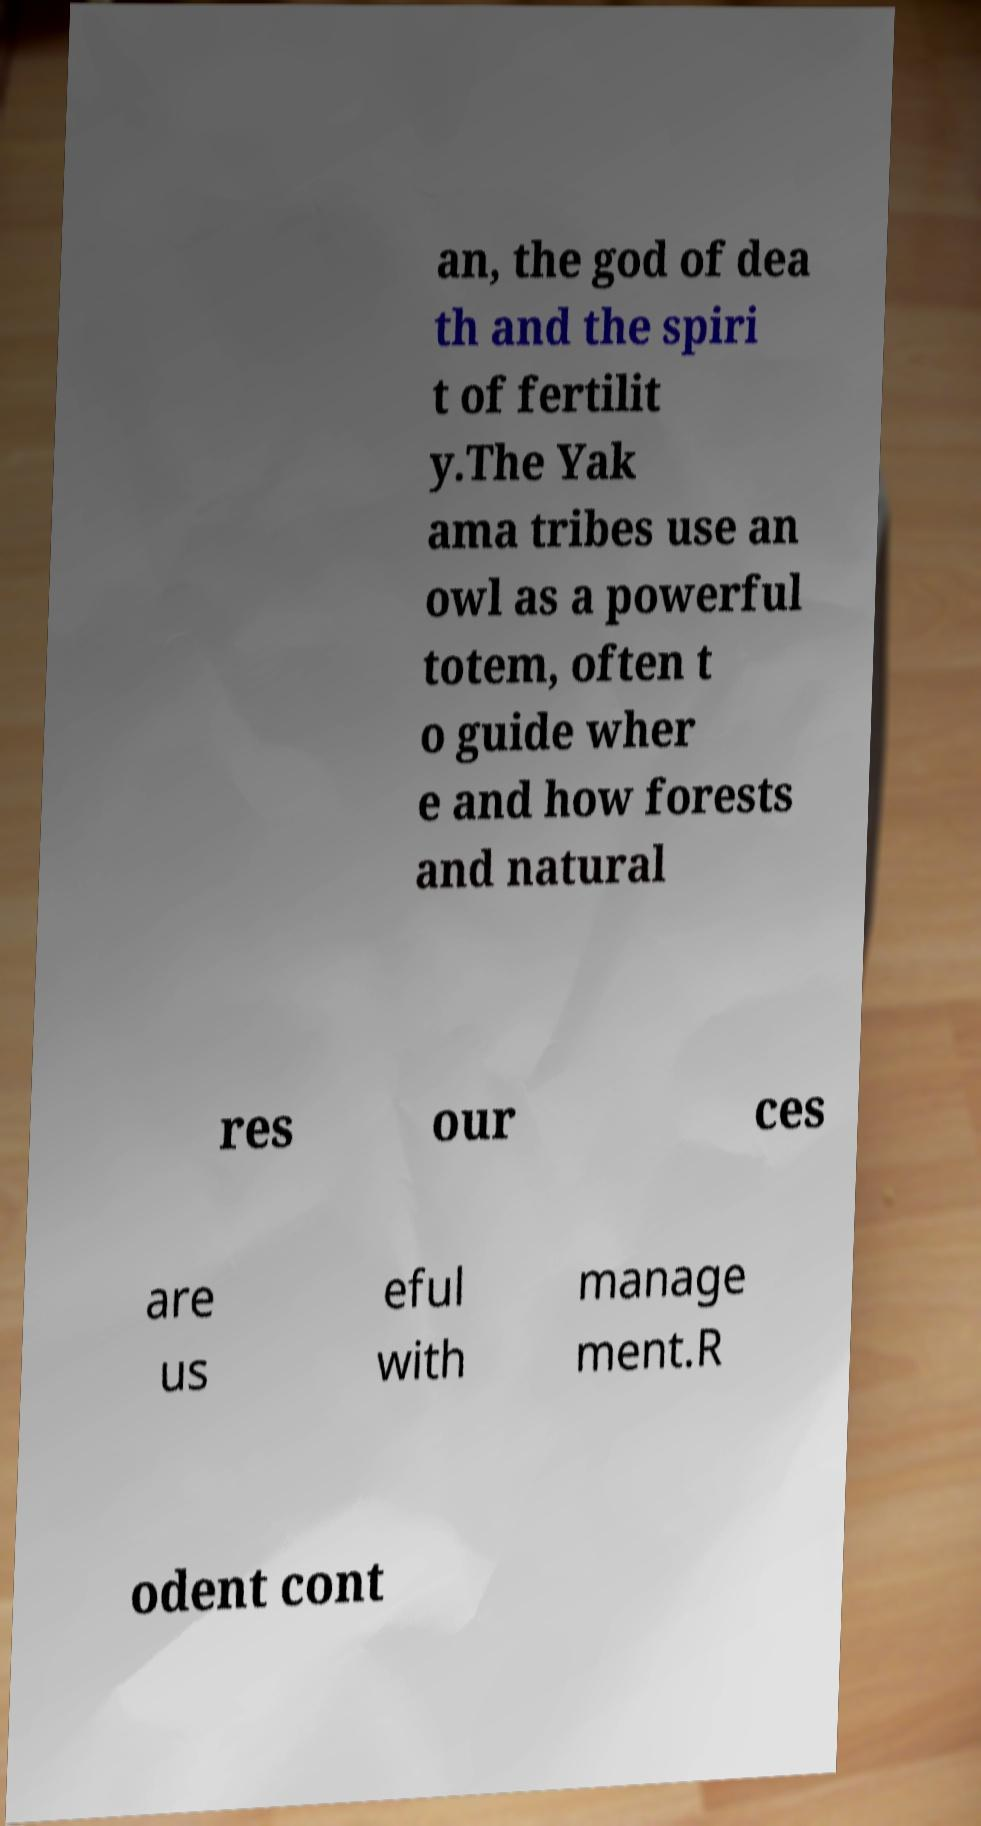I need the written content from this picture converted into text. Can you do that? an, the god of dea th and the spiri t of fertilit y.The Yak ama tribes use an owl as a powerful totem, often t o guide wher e and how forests and natural res our ces are us eful with manage ment.R odent cont 